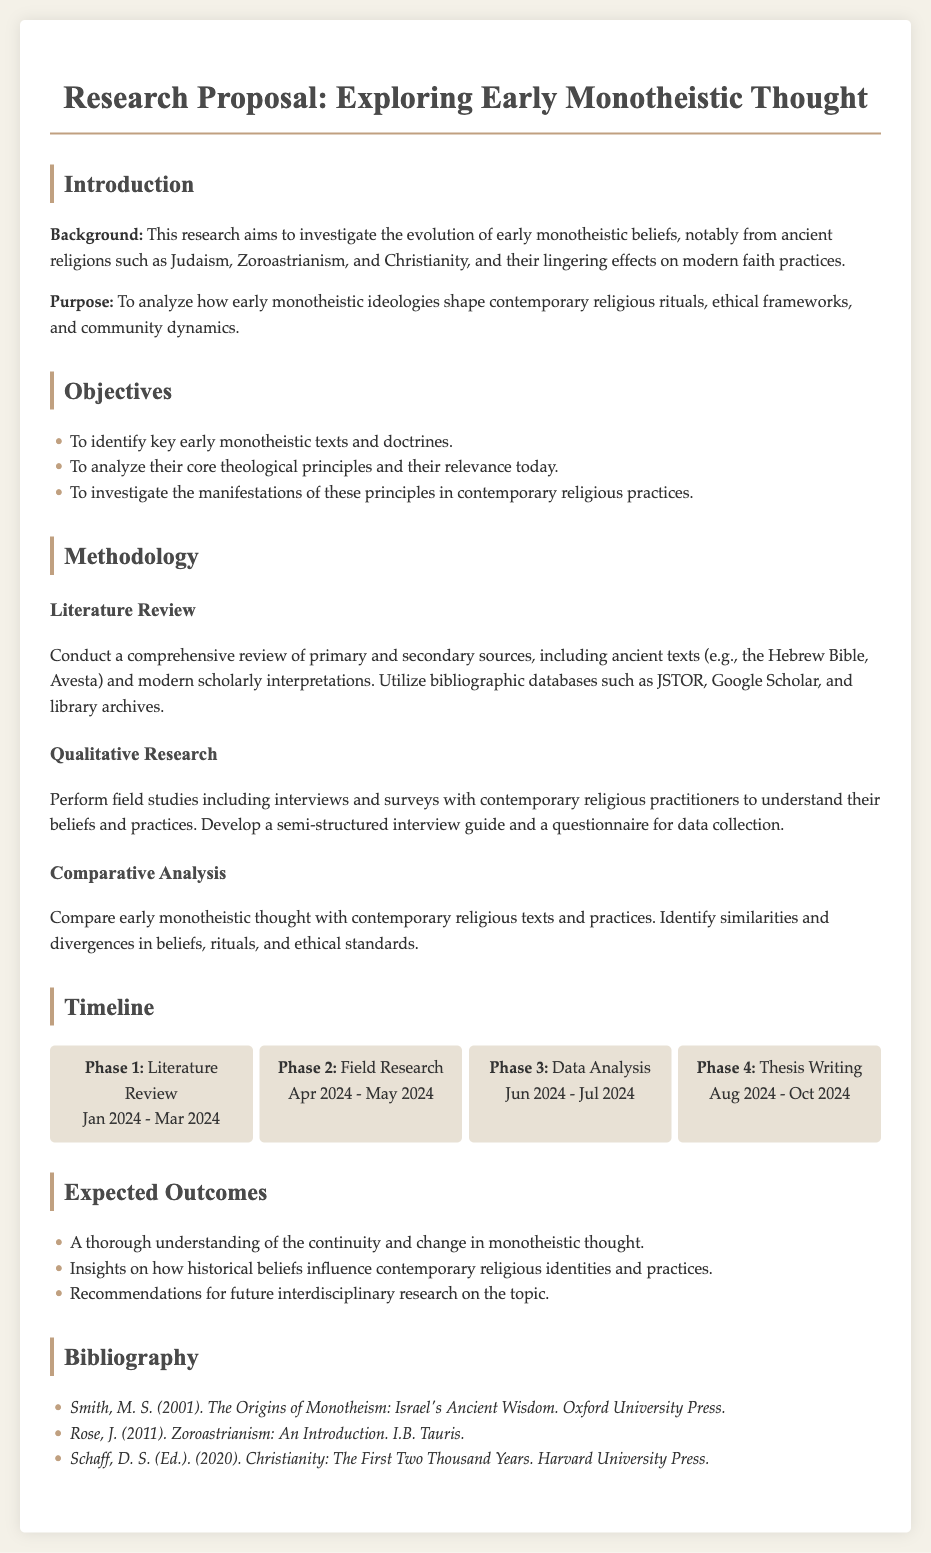What is the title of the research proposal? The title of the research proposal is explicitly mentioned in the document's header section.
Answer: Exploring Early Monotheistic Thought What is the time frame for the literature review phase? The timeline section lists the specific months for each phase of the research project, including the literature review.
Answer: Jan 2024 - Mar 2024 Which ancient texts will be analyzed in the literature review? The methodology section specifies the sources to be reviewed, including some examples of ancient texts.
Answer: Hebrew Bible, Avesta What is the main aim of this research? The introduction outlines the purpose of the research succinctly, focusing on the relationship between early and contemporary monotheistic beliefs.
Answer: To analyze how early monotheistic ideologies shape contemporary religious rituals, ethical frameworks, and community dynamics What methods will be used for qualitative research? The methodology section details how qualitative data will be collected, specifying tools and approaches used for gathering primary information.
Answer: Interviews and surveys What are the expected outcomes of this research? The expected outcomes are derived from the outcomes section which highlights the goals of the study in terms of understanding and recommendations.
Answer: Continuity and change in monotheistic thought How many phases are outlined in the research timeline? The timeline section breaks down the entire research process into distinct phases, which can be counted for clarity.
Answer: Four phases What type of analysis will be conducted with early monotheistic thought? The methodology section specifically outlines a type of comparative examination that will take place.
Answer: Comparative Analysis Which bibliography reference is associated with Zoroastrianism? The bibliography includes references with authors and their contributions, allowing identification of specific works related to the study.
Answer: Rose, J. (2011). Zoroastrianism: An Introduction. I.B. Tauris 